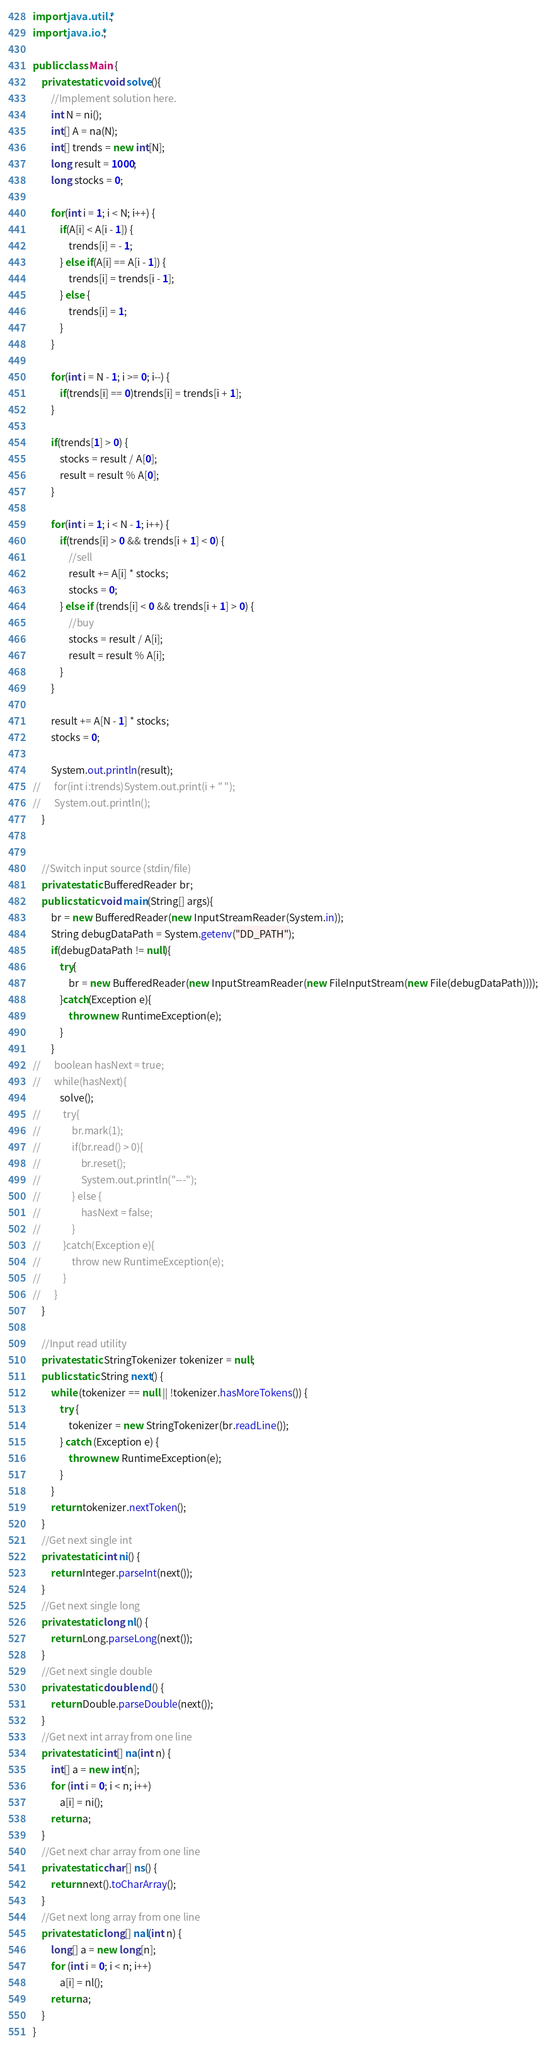Convert code to text. <code><loc_0><loc_0><loc_500><loc_500><_Java_>import java.util.*;
import java.io.*;

public class Main {
	private static void solve(){
		//Implement solution here.
		int N = ni();
		int[] A = na(N);
		int[] trends = new int[N];
		long result = 1000;
		long stocks = 0;
		
		for(int i = 1; i < N; i++) {
			if(A[i] < A[i - 1]) {
				trends[i] = - 1;
			} else if(A[i] == A[i - 1]) {
				trends[i] = trends[i - 1];
			} else {
				trends[i] = 1;
			}
		}
		
		for(int i = N - 1; i >= 0; i--) {
			if(trends[i] == 0)trends[i] = trends[i + 1];
		}
		
		if(trends[1] > 0) {			
			stocks = result / A[0];
			result = result % A[0];			
		}
		
		for(int i = 1; i < N - 1; i++) {
			if(trends[i] > 0 && trends[i + 1] < 0) {
				//sell
				result += A[i] * stocks;
				stocks = 0;
			} else if (trends[i] < 0 && trends[i + 1] > 0) {
				//buy
				stocks = result / A[i];
				result = result % A[i];				
			}
		}
		
		result += A[N - 1] * stocks;
		stocks = 0;
		
		System.out.println(result);
//		for(int i:trends)System.out.print(i + " ");
//		System.out.println();
	}


	//Switch input source (stdin/file)
	private static BufferedReader br;
	public static void main(String[] args){
		br = new BufferedReader(new InputStreamReader(System.in));
		String debugDataPath = System.getenv("DD_PATH");        
		if(debugDataPath != null){
			try{
				br = new BufferedReader(new InputStreamReader(new FileInputStream(new File(debugDataPath))));
			}catch(Exception e){
				throw new RuntimeException(e);
			}
		}
//		boolean hasNext = true;
//		while(hasNext){
			solve();	
//			try{
//				br.mark(1);
//				if(br.read() > 0){
//					br.reset();			
//					System.out.println("---");
//				} else {
//					hasNext = false;
//				}
//			}catch(Exception e){
//				throw new RuntimeException(e);
//			} 
//		}
	}

	//Input read utility
	private static StringTokenizer tokenizer = null;
	public static String next() {
		while (tokenizer == null || !tokenizer.hasMoreTokens()) {
			try {
				tokenizer = new StringTokenizer(br.readLine());
			} catch (Exception e) {
				throw new RuntimeException(e);
			}
		}
		return tokenizer.nextToken();
	}
	//Get next single int
	private static int ni() {
		return Integer.parseInt(next());
	}
	//Get next single long
	private static long nl() {
		return Long.parseLong(next());
	}
	//Get next single double
	private static double nd() {
		return Double.parseDouble(next());
	}
	//Get next int array from one line
	private static int[] na(int n) {
		int[] a = new int[n];
		for (int i = 0; i < n; i++)
			a[i] = ni();
		return a;
	}
	//Get next char array from one line
	private static char[] ns() {
		return next().toCharArray();
	}
	//Get next long array from one line
	private static long[] nal(int n) {
		long[] a = new long[n];
		for (int i = 0; i < n; i++)
			a[i] = nl();
		return a;
	}
}
</code> 